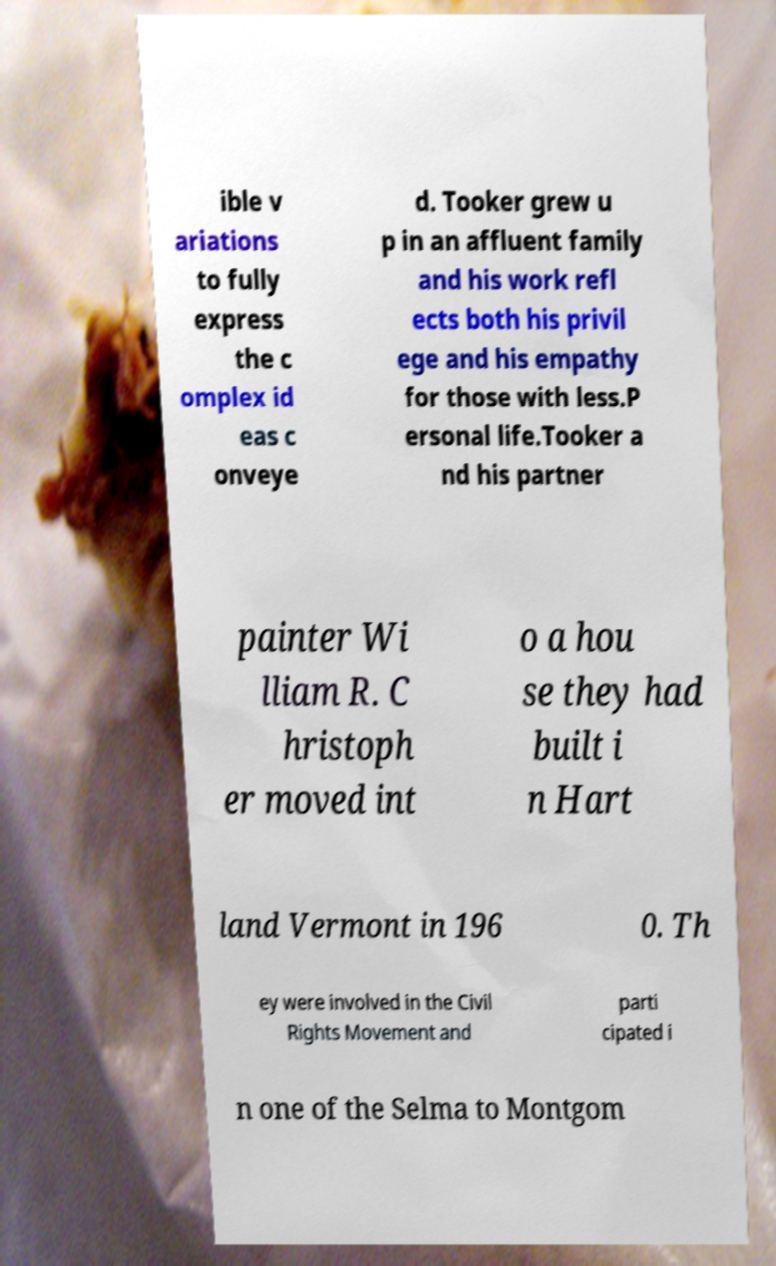What messages or text are displayed in this image? I need them in a readable, typed format. ible v ariations to fully express the c omplex id eas c onveye d. Tooker grew u p in an affluent family and his work refl ects both his privil ege and his empathy for those with less.P ersonal life.Tooker a nd his partner painter Wi lliam R. C hristoph er moved int o a hou se they had built i n Hart land Vermont in 196 0. Th ey were involved in the Civil Rights Movement and parti cipated i n one of the Selma to Montgom 